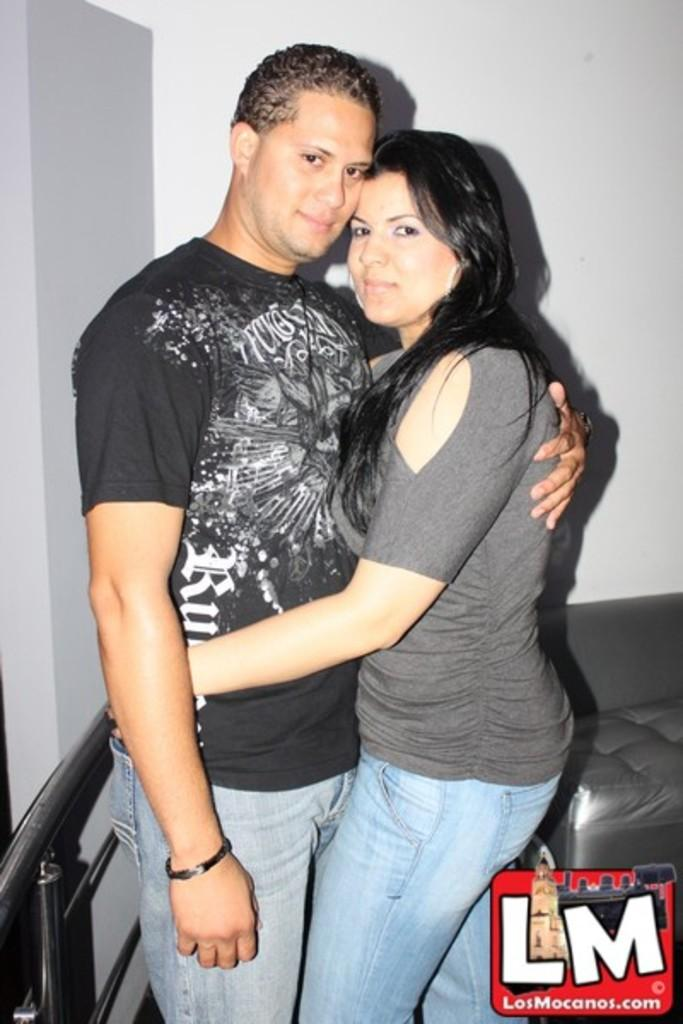How many people are in the image? There are two persons standing in the image. What is the person on the left wearing? The person on the left is wearing a black t-shirt. What can be seen behind the two persons? There is a sofa in the background of the image. What is the primary architectural feature visible in the image? There is a wall visible in the image. What type of spot can be seen on the wall in the image? There is no spot visible on the wall in the image. What kind of test is being conducted in the image? There is no test being conducted in the image; it features two persons standing near a sofa and a wall. 